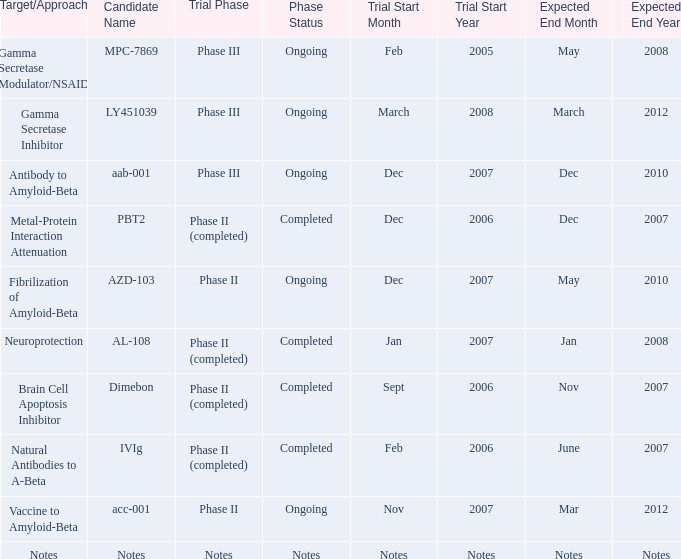What is Candidate Name, when Target/Approach is "vaccine to amyloid-beta"? Acc-001. 